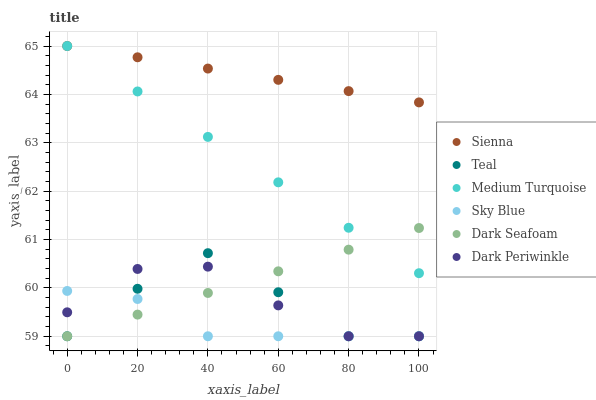Does Sky Blue have the minimum area under the curve?
Answer yes or no. Yes. Does Sienna have the maximum area under the curve?
Answer yes or no. Yes. Does Dark Seafoam have the minimum area under the curve?
Answer yes or no. No. Does Dark Seafoam have the maximum area under the curve?
Answer yes or no. No. Is Dark Seafoam the smoothest?
Answer yes or no. Yes. Is Teal the roughest?
Answer yes or no. Yes. Is Sienna the smoothest?
Answer yes or no. No. Is Sienna the roughest?
Answer yes or no. No. Does Teal have the lowest value?
Answer yes or no. Yes. Does Sienna have the lowest value?
Answer yes or no. No. Does Medium Turquoise have the highest value?
Answer yes or no. Yes. Does Dark Seafoam have the highest value?
Answer yes or no. No. Is Dark Periwinkle less than Medium Turquoise?
Answer yes or no. Yes. Is Medium Turquoise greater than Dark Periwinkle?
Answer yes or no. Yes. Does Dark Periwinkle intersect Teal?
Answer yes or no. Yes. Is Dark Periwinkle less than Teal?
Answer yes or no. No. Is Dark Periwinkle greater than Teal?
Answer yes or no. No. Does Dark Periwinkle intersect Medium Turquoise?
Answer yes or no. No. 